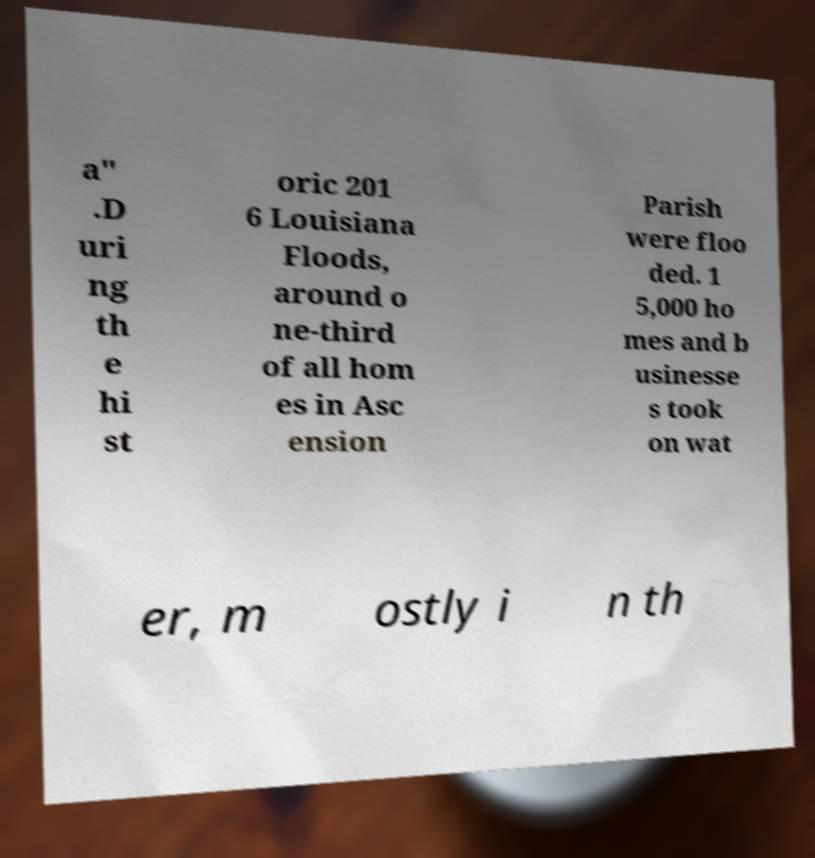I need the written content from this picture converted into text. Can you do that? a" .D uri ng th e hi st oric 201 6 Louisiana Floods, around o ne-third of all hom es in Asc ension Parish were floo ded. 1 5,000 ho mes and b usinesse s took on wat er, m ostly i n th 